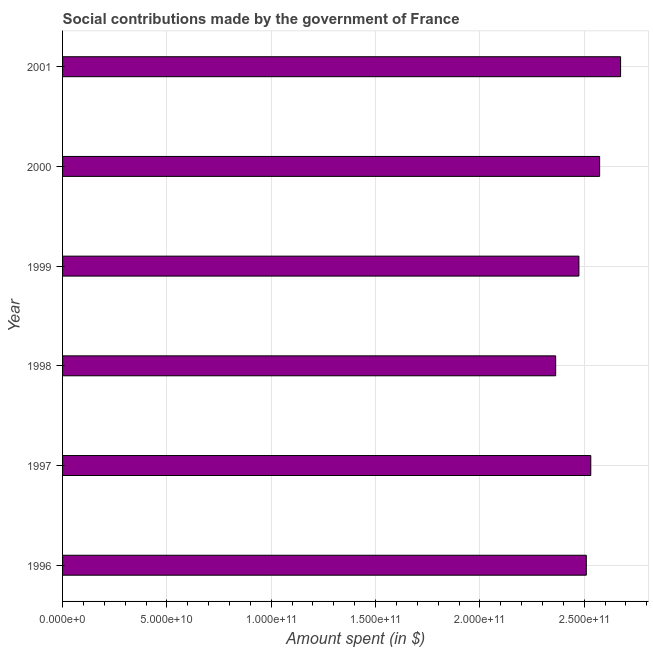What is the title of the graph?
Provide a succinct answer. Social contributions made by the government of France. What is the label or title of the X-axis?
Offer a very short reply. Amount spent (in $). What is the label or title of the Y-axis?
Make the answer very short. Year. What is the amount spent in making social contributions in 1999?
Provide a succinct answer. 2.47e+11. Across all years, what is the maximum amount spent in making social contributions?
Offer a terse response. 2.67e+11. Across all years, what is the minimum amount spent in making social contributions?
Offer a terse response. 2.36e+11. What is the sum of the amount spent in making social contributions?
Offer a very short reply. 1.51e+12. What is the difference between the amount spent in making social contributions in 1997 and 2000?
Make the answer very short. -4.24e+09. What is the average amount spent in making social contributions per year?
Your answer should be compact. 2.52e+11. What is the median amount spent in making social contributions?
Your answer should be compact. 2.52e+11. In how many years, is the amount spent in making social contributions greater than 220000000000 $?
Provide a succinct answer. 6. What is the ratio of the amount spent in making social contributions in 1998 to that in 2000?
Give a very brief answer. 0.92. Is the amount spent in making social contributions in 1996 less than that in 1997?
Offer a very short reply. Yes. What is the difference between the highest and the second highest amount spent in making social contributions?
Offer a very short reply. 1.00e+1. What is the difference between the highest and the lowest amount spent in making social contributions?
Your answer should be compact. 3.11e+1. How many bars are there?
Offer a terse response. 6. What is the Amount spent (in $) in 1996?
Your response must be concise. 2.51e+11. What is the Amount spent (in $) of 1997?
Ensure brevity in your answer.  2.53e+11. What is the Amount spent (in $) in 1998?
Offer a very short reply. 2.36e+11. What is the Amount spent (in $) of 1999?
Give a very brief answer. 2.47e+11. What is the Amount spent (in $) of 2000?
Give a very brief answer. 2.57e+11. What is the Amount spent (in $) of 2001?
Keep it short and to the point. 2.67e+11. What is the difference between the Amount spent (in $) in 1996 and 1997?
Give a very brief answer. -2.15e+09. What is the difference between the Amount spent (in $) in 1996 and 1998?
Ensure brevity in your answer.  1.47e+1. What is the difference between the Amount spent (in $) in 1996 and 1999?
Your answer should be very brief. 3.55e+09. What is the difference between the Amount spent (in $) in 1996 and 2000?
Keep it short and to the point. -6.39e+09. What is the difference between the Amount spent (in $) in 1996 and 2001?
Make the answer very short. -1.64e+1. What is the difference between the Amount spent (in $) in 1997 and 1998?
Keep it short and to the point. 1.68e+1. What is the difference between the Amount spent (in $) in 1997 and 1999?
Provide a short and direct response. 5.70e+09. What is the difference between the Amount spent (in $) in 1997 and 2000?
Provide a succinct answer. -4.24e+09. What is the difference between the Amount spent (in $) in 1997 and 2001?
Give a very brief answer. -1.43e+1. What is the difference between the Amount spent (in $) in 1998 and 1999?
Provide a short and direct response. -1.11e+1. What is the difference between the Amount spent (in $) in 1998 and 2000?
Your answer should be very brief. -2.11e+1. What is the difference between the Amount spent (in $) in 1998 and 2001?
Provide a short and direct response. -3.11e+1. What is the difference between the Amount spent (in $) in 1999 and 2000?
Provide a short and direct response. -9.94e+09. What is the difference between the Amount spent (in $) in 1999 and 2001?
Your answer should be very brief. -2.00e+1. What is the difference between the Amount spent (in $) in 2000 and 2001?
Keep it short and to the point. -1.00e+1. What is the ratio of the Amount spent (in $) in 1996 to that in 1998?
Your answer should be compact. 1.06. What is the ratio of the Amount spent (in $) in 1996 to that in 2001?
Ensure brevity in your answer.  0.94. What is the ratio of the Amount spent (in $) in 1997 to that in 1998?
Your answer should be compact. 1.07. What is the ratio of the Amount spent (in $) in 1997 to that in 2001?
Your answer should be very brief. 0.95. What is the ratio of the Amount spent (in $) in 1998 to that in 1999?
Provide a succinct answer. 0.95. What is the ratio of the Amount spent (in $) in 1998 to that in 2000?
Your response must be concise. 0.92. What is the ratio of the Amount spent (in $) in 1998 to that in 2001?
Make the answer very short. 0.88. What is the ratio of the Amount spent (in $) in 1999 to that in 2001?
Provide a succinct answer. 0.93. What is the ratio of the Amount spent (in $) in 2000 to that in 2001?
Give a very brief answer. 0.96. 